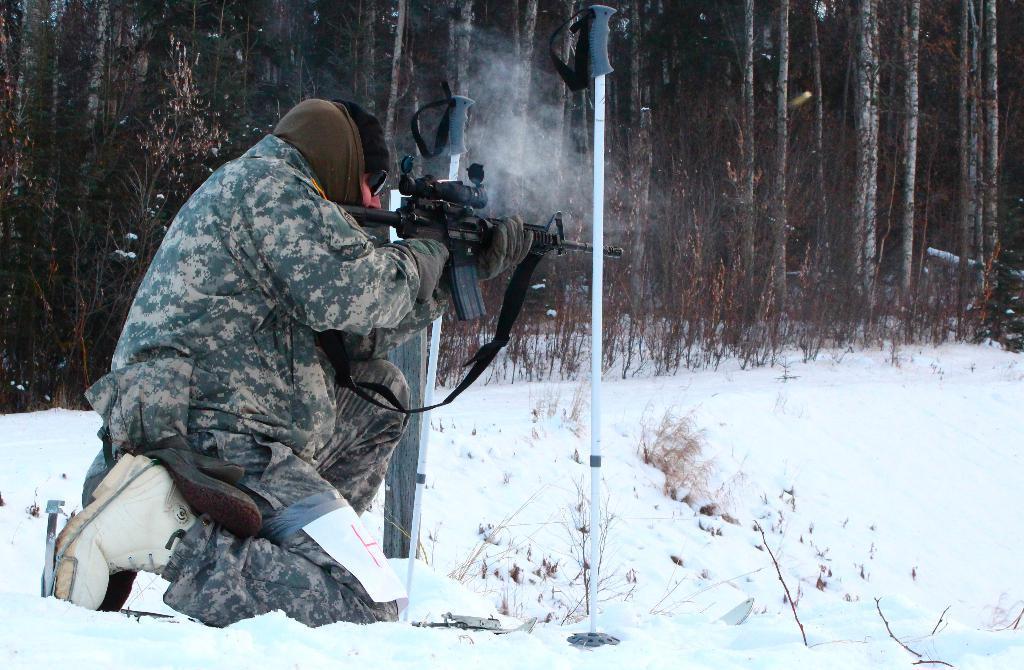Can you describe this image briefly? In this image, we can see a man bending on his knees and wearing uniform, glasses, a cap, scarf, gloves and we can see a belt with paper and holding a gun. In the background, there are trees and we can see sticks. At the bottom, there is snow. 